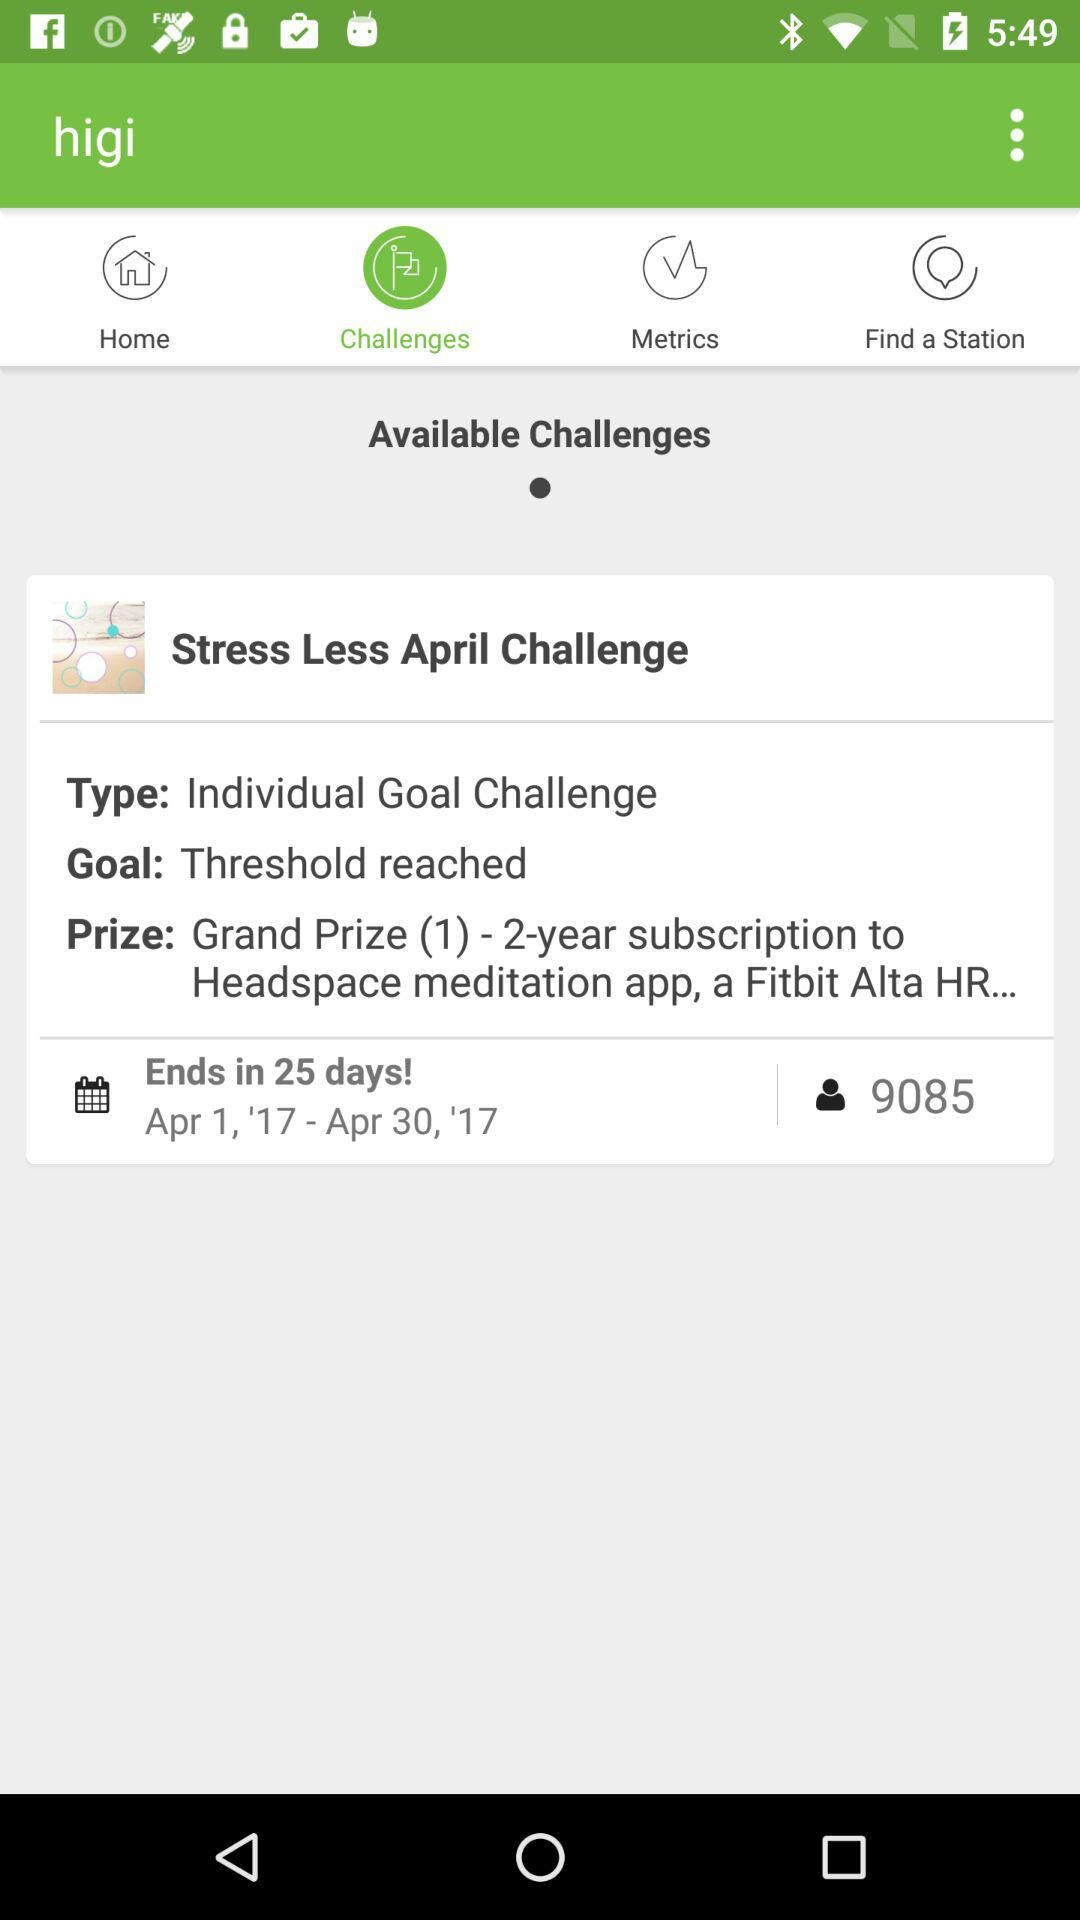What is the end date of the "Stress Less April Challenge"? The end date of the "Stress Less April Challenge" is April 30, 2017. 